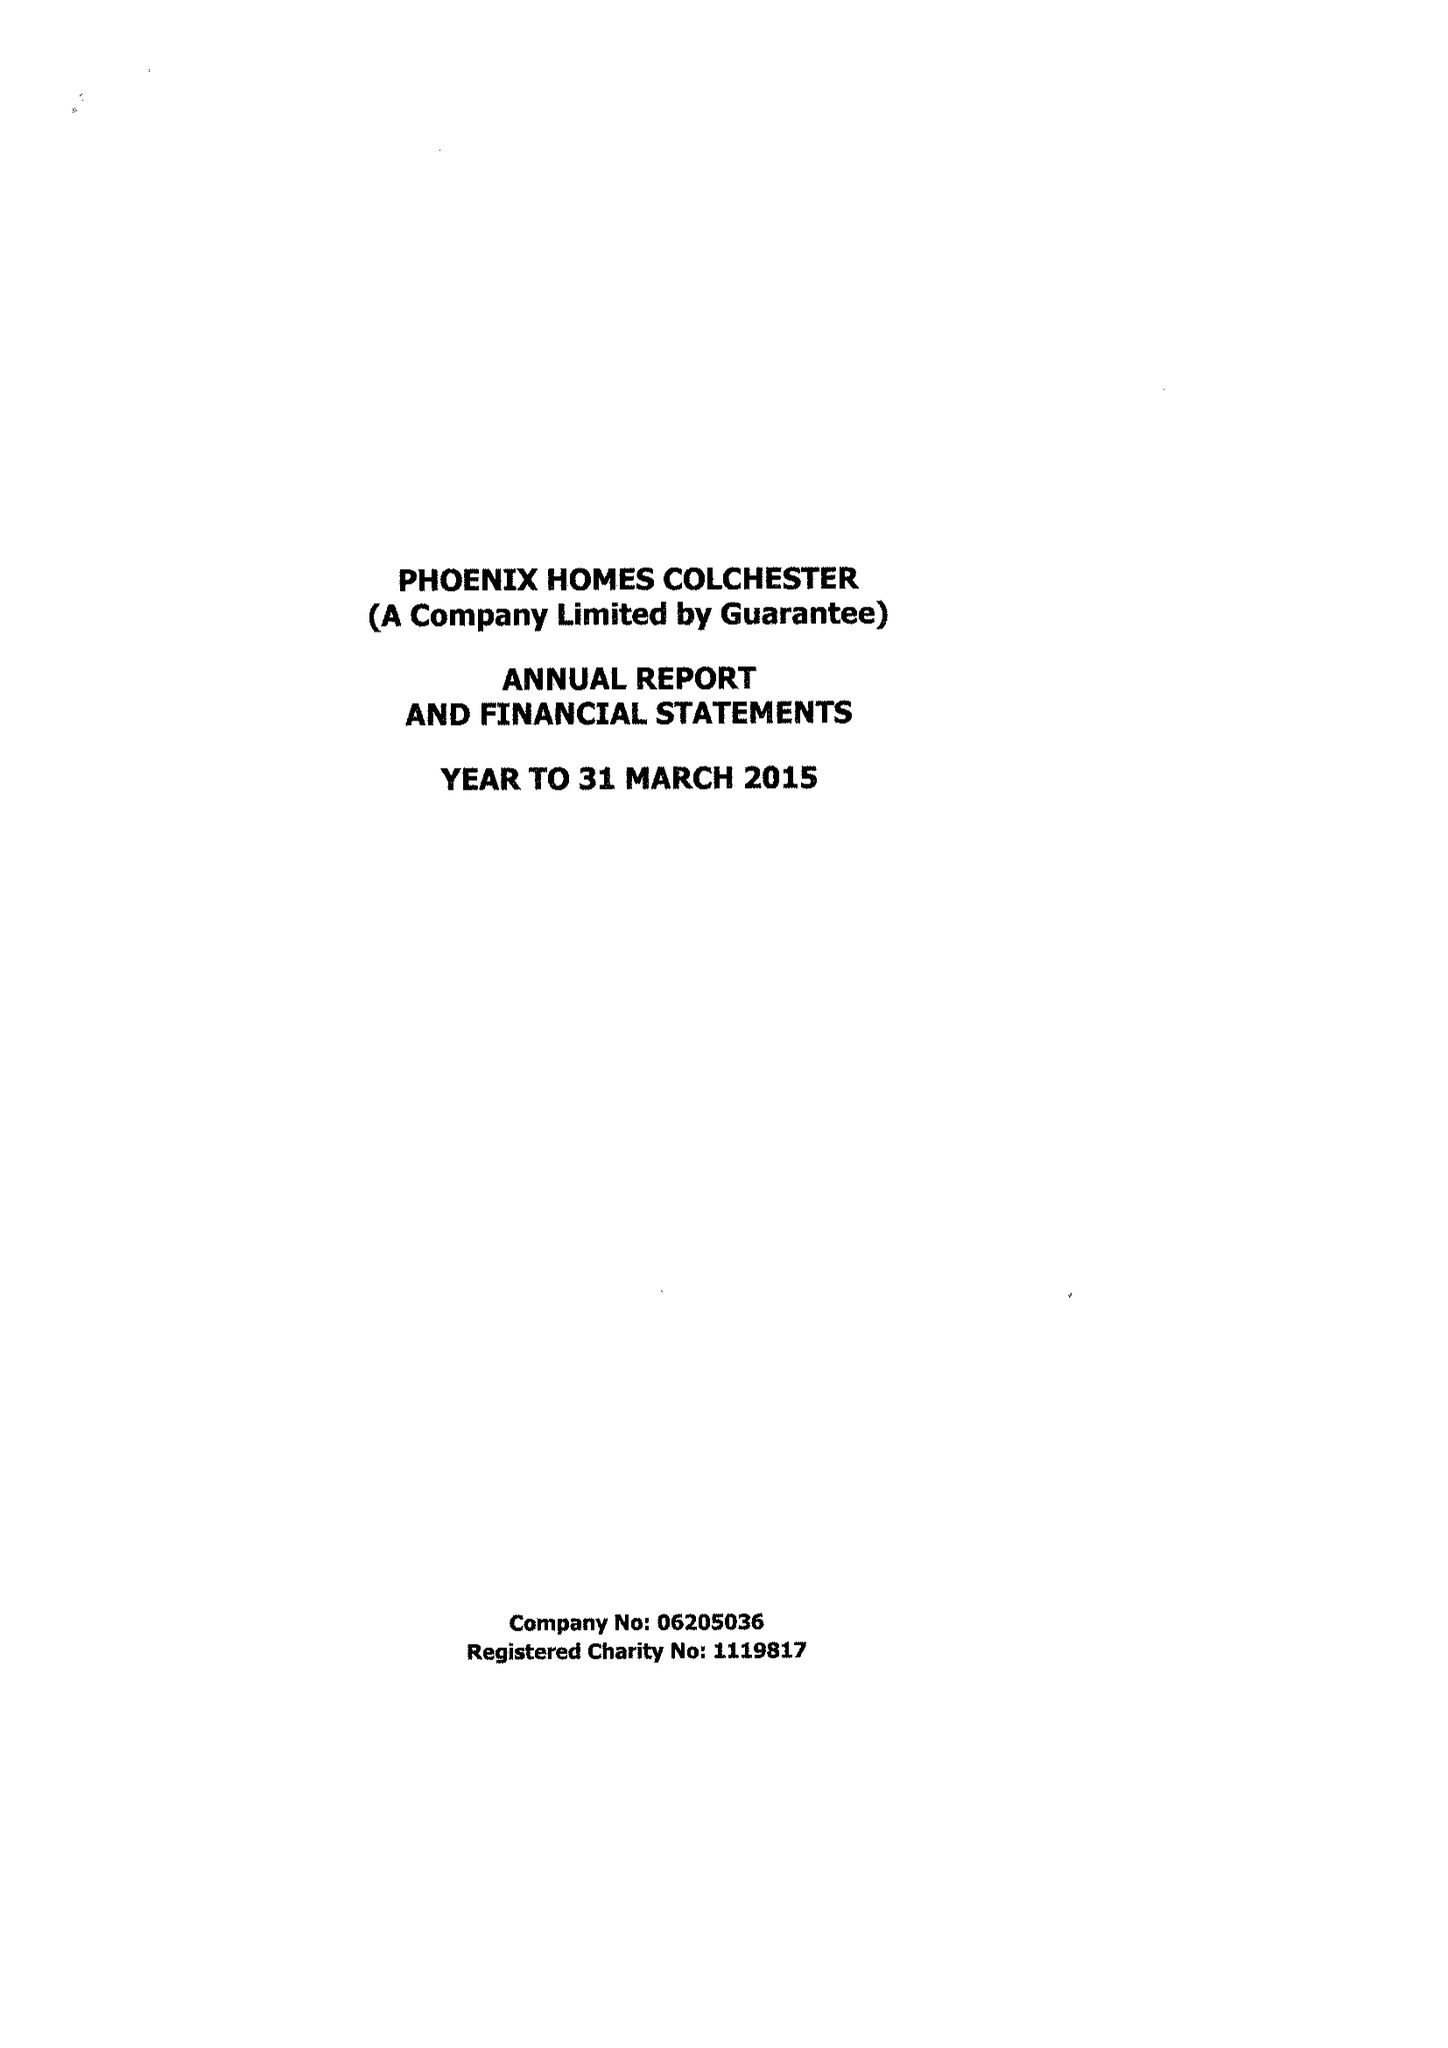What is the value for the address__postcode?
Answer the question using a single word or phrase. CO3 9DE 